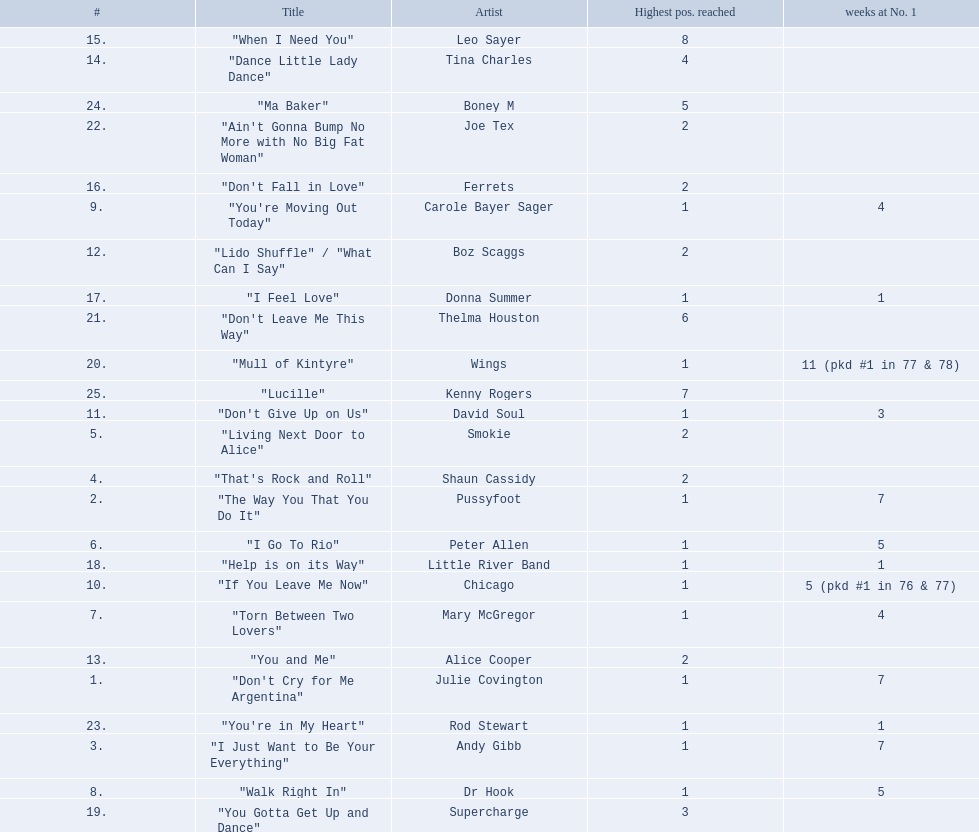Which artists were included in the top 25 singles for 1977 in australia? Julie Covington, Pussyfoot, Andy Gibb, Shaun Cassidy, Smokie, Peter Allen, Mary McGregor, Dr Hook, Carole Bayer Sager, Chicago, David Soul, Boz Scaggs, Alice Cooper, Tina Charles, Leo Sayer, Ferrets, Donna Summer, Little River Band, Supercharge, Wings, Thelma Houston, Joe Tex, Rod Stewart, Boney M, Kenny Rogers. And for how many weeks did they chart at number 1? 7, 7, 7, , , 5, 4, 5, 4, 5 (pkd #1 in 76 & 77), 3, , , , , , 1, 1, , 11 (pkd #1 in 77 & 78), , , 1, , . Which artist was in the number 1 spot for most time? Wings. 